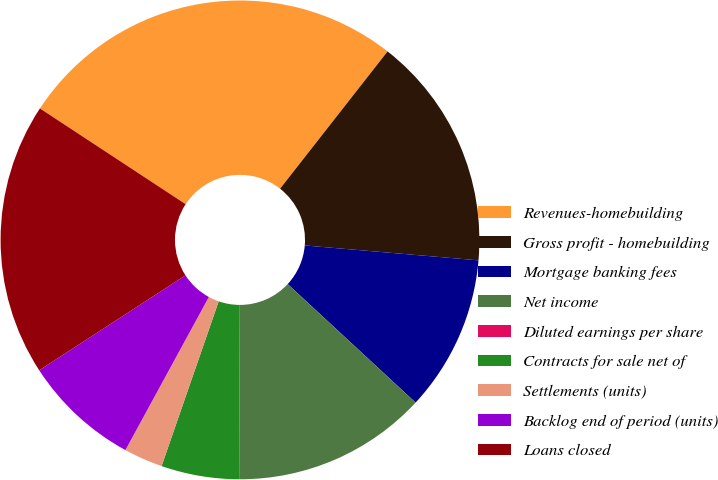<chart> <loc_0><loc_0><loc_500><loc_500><pie_chart><fcel>Revenues-homebuilding<fcel>Gross profit - homebuilding<fcel>Mortgage banking fees<fcel>Net income<fcel>Diluted earnings per share<fcel>Contracts for sale net of<fcel>Settlements (units)<fcel>Backlog end of period (units)<fcel>Loans closed<nl><fcel>26.32%<fcel>15.79%<fcel>10.53%<fcel>13.16%<fcel>0.0%<fcel>5.26%<fcel>2.63%<fcel>7.89%<fcel>18.42%<nl></chart> 